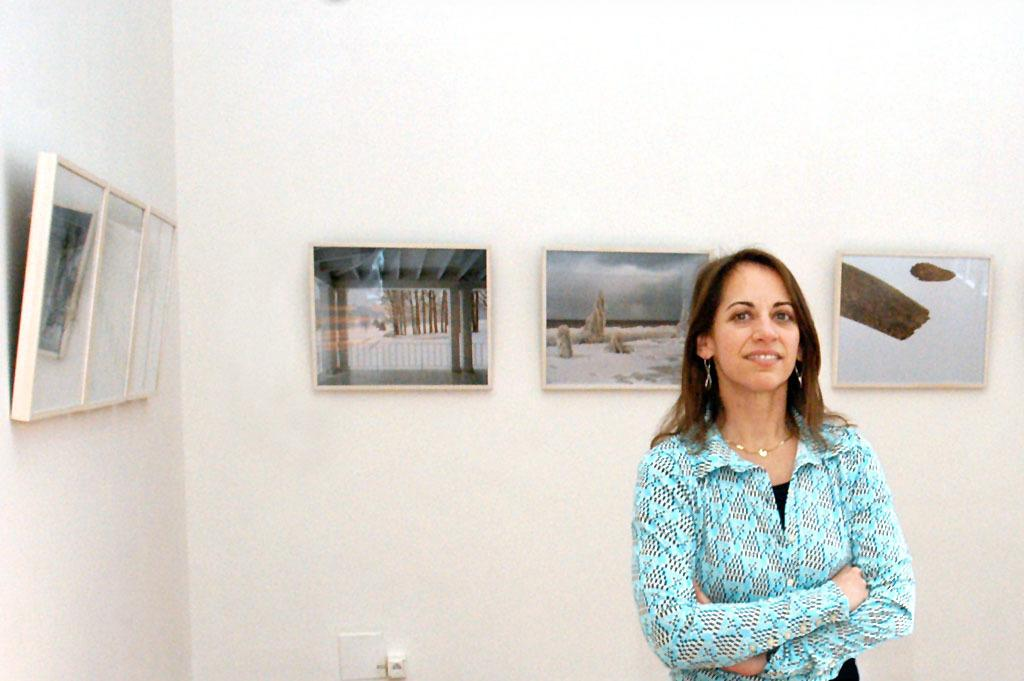Who is the main subject in the image? There is a woman in the image. Where is the woman positioned in relation to the wall? The woman is standing near a wall. What can be seen on the wall in the image? There are many photo frames on the wall. What type of feature is present at the bottom of the wall? There is a socket at the bottom of the wall. What type of credit card does the girl in the image use for her health expenses? There is no girl present in the image, and no information about credit cards or health expenses is provided. 